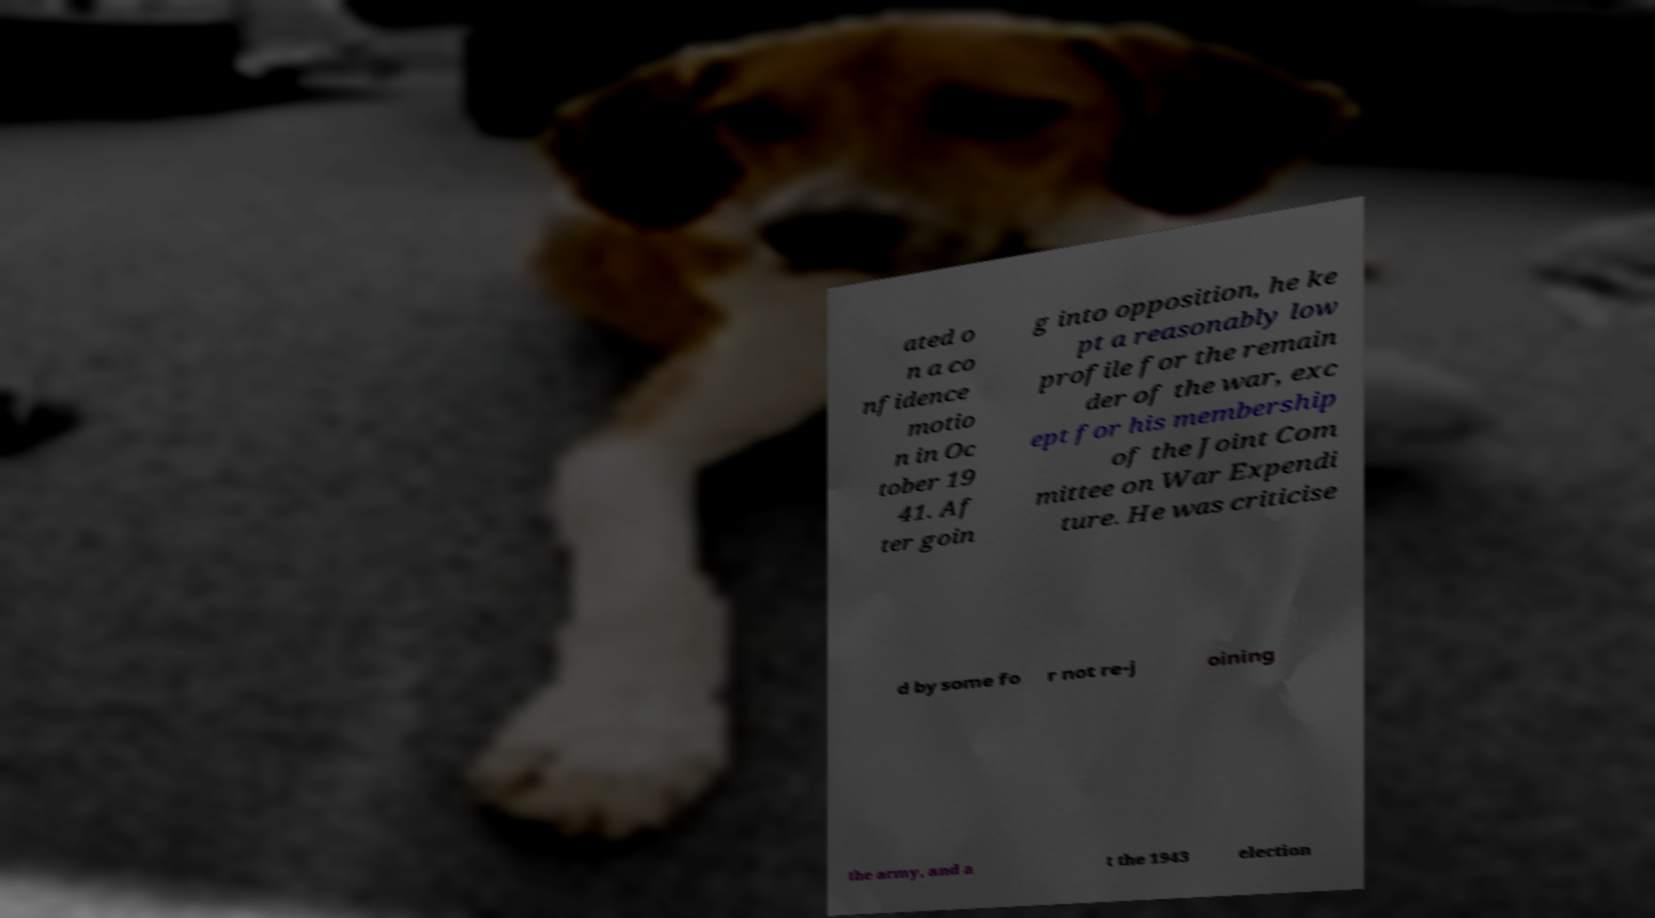Please read and relay the text visible in this image. What does it say? ated o n a co nfidence motio n in Oc tober 19 41. Af ter goin g into opposition, he ke pt a reasonably low profile for the remain der of the war, exc ept for his membership of the Joint Com mittee on War Expendi ture. He was criticise d by some fo r not re-j oining the army, and a t the 1943 election 